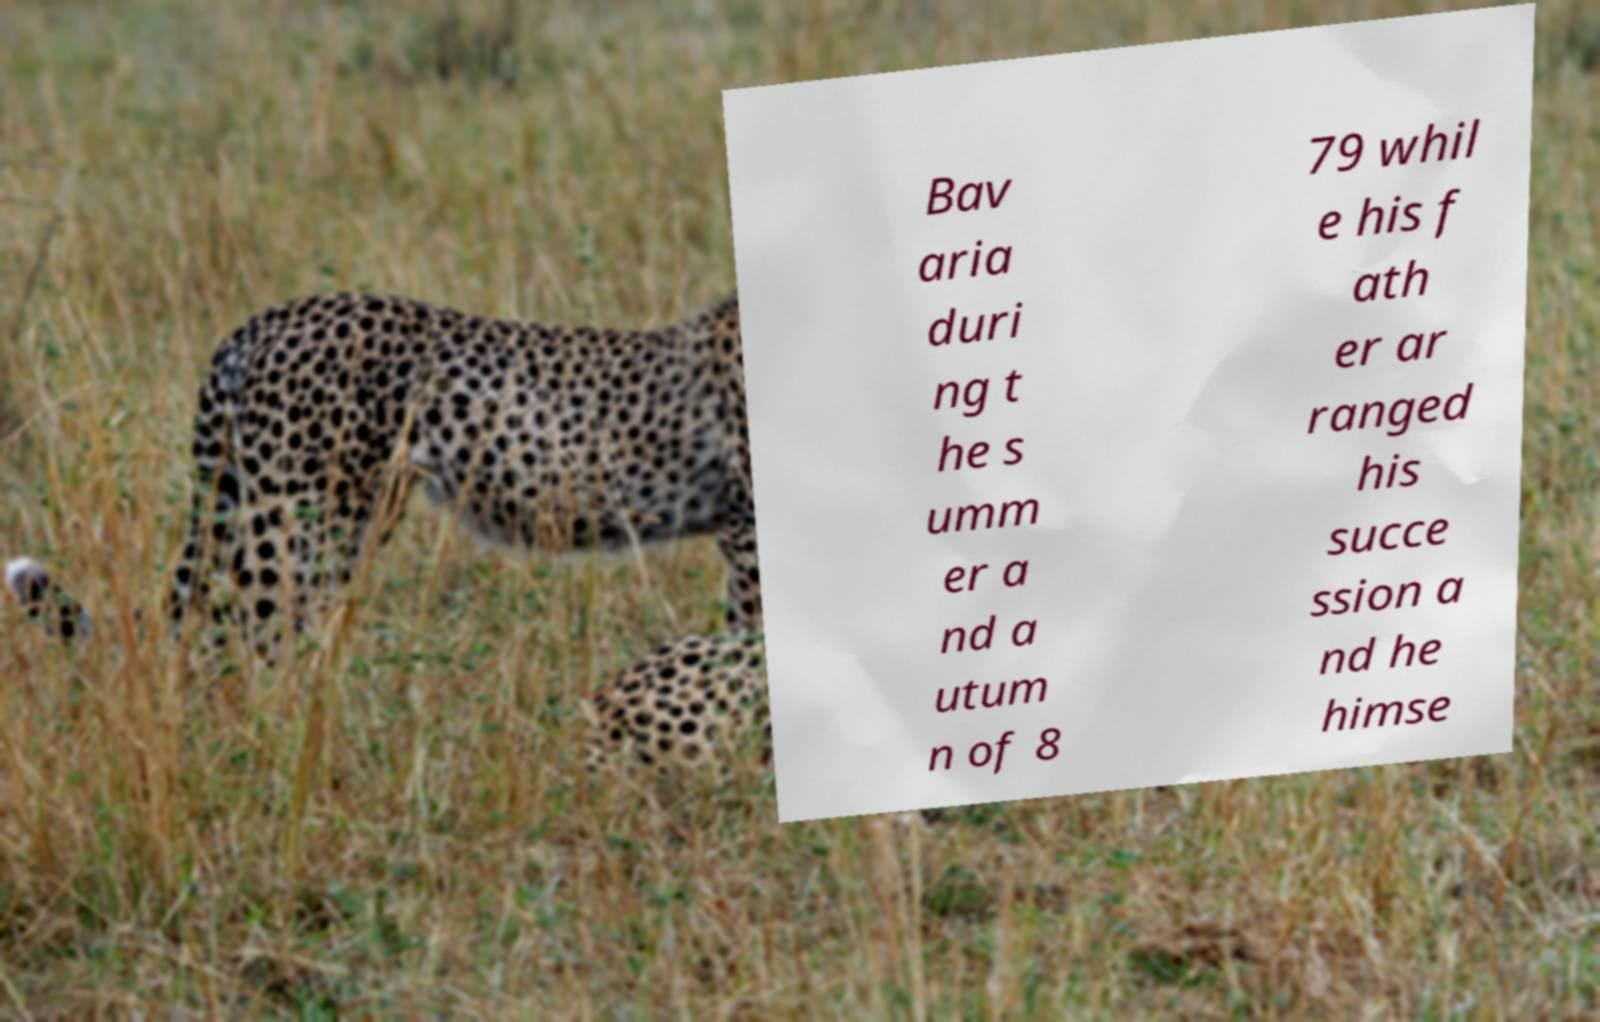For documentation purposes, I need the text within this image transcribed. Could you provide that? Bav aria duri ng t he s umm er a nd a utum n of 8 79 whil e his f ath er ar ranged his succe ssion a nd he himse 